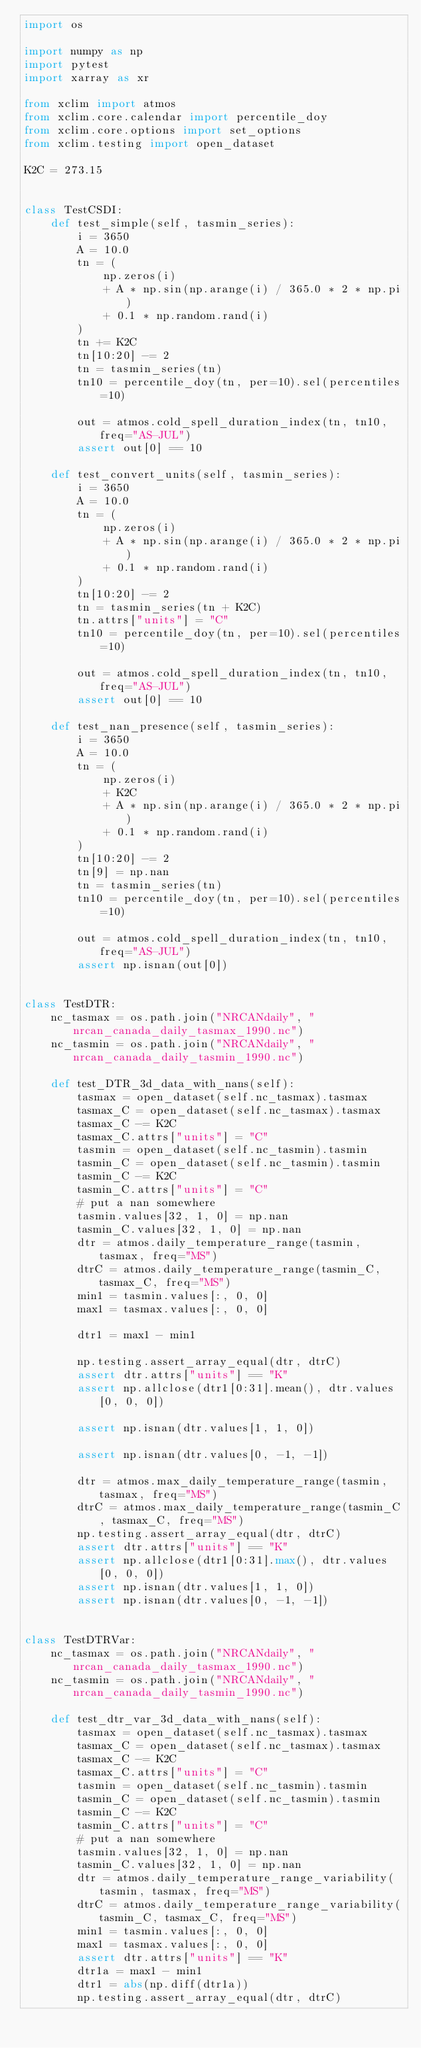<code> <loc_0><loc_0><loc_500><loc_500><_Python_>import os

import numpy as np
import pytest
import xarray as xr

from xclim import atmos
from xclim.core.calendar import percentile_doy
from xclim.core.options import set_options
from xclim.testing import open_dataset

K2C = 273.15


class TestCSDI:
    def test_simple(self, tasmin_series):
        i = 3650
        A = 10.0
        tn = (
            np.zeros(i)
            + A * np.sin(np.arange(i) / 365.0 * 2 * np.pi)
            + 0.1 * np.random.rand(i)
        )
        tn += K2C
        tn[10:20] -= 2
        tn = tasmin_series(tn)
        tn10 = percentile_doy(tn, per=10).sel(percentiles=10)

        out = atmos.cold_spell_duration_index(tn, tn10, freq="AS-JUL")
        assert out[0] == 10

    def test_convert_units(self, tasmin_series):
        i = 3650
        A = 10.0
        tn = (
            np.zeros(i)
            + A * np.sin(np.arange(i) / 365.0 * 2 * np.pi)
            + 0.1 * np.random.rand(i)
        )
        tn[10:20] -= 2
        tn = tasmin_series(tn + K2C)
        tn.attrs["units"] = "C"
        tn10 = percentile_doy(tn, per=10).sel(percentiles=10)

        out = atmos.cold_spell_duration_index(tn, tn10, freq="AS-JUL")
        assert out[0] == 10

    def test_nan_presence(self, tasmin_series):
        i = 3650
        A = 10.0
        tn = (
            np.zeros(i)
            + K2C
            + A * np.sin(np.arange(i) / 365.0 * 2 * np.pi)
            + 0.1 * np.random.rand(i)
        )
        tn[10:20] -= 2
        tn[9] = np.nan
        tn = tasmin_series(tn)
        tn10 = percentile_doy(tn, per=10).sel(percentiles=10)

        out = atmos.cold_spell_duration_index(tn, tn10, freq="AS-JUL")
        assert np.isnan(out[0])


class TestDTR:
    nc_tasmax = os.path.join("NRCANdaily", "nrcan_canada_daily_tasmax_1990.nc")
    nc_tasmin = os.path.join("NRCANdaily", "nrcan_canada_daily_tasmin_1990.nc")

    def test_DTR_3d_data_with_nans(self):
        tasmax = open_dataset(self.nc_tasmax).tasmax
        tasmax_C = open_dataset(self.nc_tasmax).tasmax
        tasmax_C -= K2C
        tasmax_C.attrs["units"] = "C"
        tasmin = open_dataset(self.nc_tasmin).tasmin
        tasmin_C = open_dataset(self.nc_tasmin).tasmin
        tasmin_C -= K2C
        tasmin_C.attrs["units"] = "C"
        # put a nan somewhere
        tasmin.values[32, 1, 0] = np.nan
        tasmin_C.values[32, 1, 0] = np.nan
        dtr = atmos.daily_temperature_range(tasmin, tasmax, freq="MS")
        dtrC = atmos.daily_temperature_range(tasmin_C, tasmax_C, freq="MS")
        min1 = tasmin.values[:, 0, 0]
        max1 = tasmax.values[:, 0, 0]

        dtr1 = max1 - min1

        np.testing.assert_array_equal(dtr, dtrC)
        assert dtr.attrs["units"] == "K"
        assert np.allclose(dtr1[0:31].mean(), dtr.values[0, 0, 0])

        assert np.isnan(dtr.values[1, 1, 0])

        assert np.isnan(dtr.values[0, -1, -1])

        dtr = atmos.max_daily_temperature_range(tasmin, tasmax, freq="MS")
        dtrC = atmos.max_daily_temperature_range(tasmin_C, tasmax_C, freq="MS")
        np.testing.assert_array_equal(dtr, dtrC)
        assert dtr.attrs["units"] == "K"
        assert np.allclose(dtr1[0:31].max(), dtr.values[0, 0, 0])
        assert np.isnan(dtr.values[1, 1, 0])
        assert np.isnan(dtr.values[0, -1, -1])


class TestDTRVar:
    nc_tasmax = os.path.join("NRCANdaily", "nrcan_canada_daily_tasmax_1990.nc")
    nc_tasmin = os.path.join("NRCANdaily", "nrcan_canada_daily_tasmin_1990.nc")

    def test_dtr_var_3d_data_with_nans(self):
        tasmax = open_dataset(self.nc_tasmax).tasmax
        tasmax_C = open_dataset(self.nc_tasmax).tasmax
        tasmax_C -= K2C
        tasmax_C.attrs["units"] = "C"
        tasmin = open_dataset(self.nc_tasmin).tasmin
        tasmin_C = open_dataset(self.nc_tasmin).tasmin
        tasmin_C -= K2C
        tasmin_C.attrs["units"] = "C"
        # put a nan somewhere
        tasmin.values[32, 1, 0] = np.nan
        tasmin_C.values[32, 1, 0] = np.nan
        dtr = atmos.daily_temperature_range_variability(tasmin, tasmax, freq="MS")
        dtrC = atmos.daily_temperature_range_variability(tasmin_C, tasmax_C, freq="MS")
        min1 = tasmin.values[:, 0, 0]
        max1 = tasmax.values[:, 0, 0]
        assert dtr.attrs["units"] == "K"
        dtr1a = max1 - min1
        dtr1 = abs(np.diff(dtr1a))
        np.testing.assert_array_equal(dtr, dtrC)
</code> 